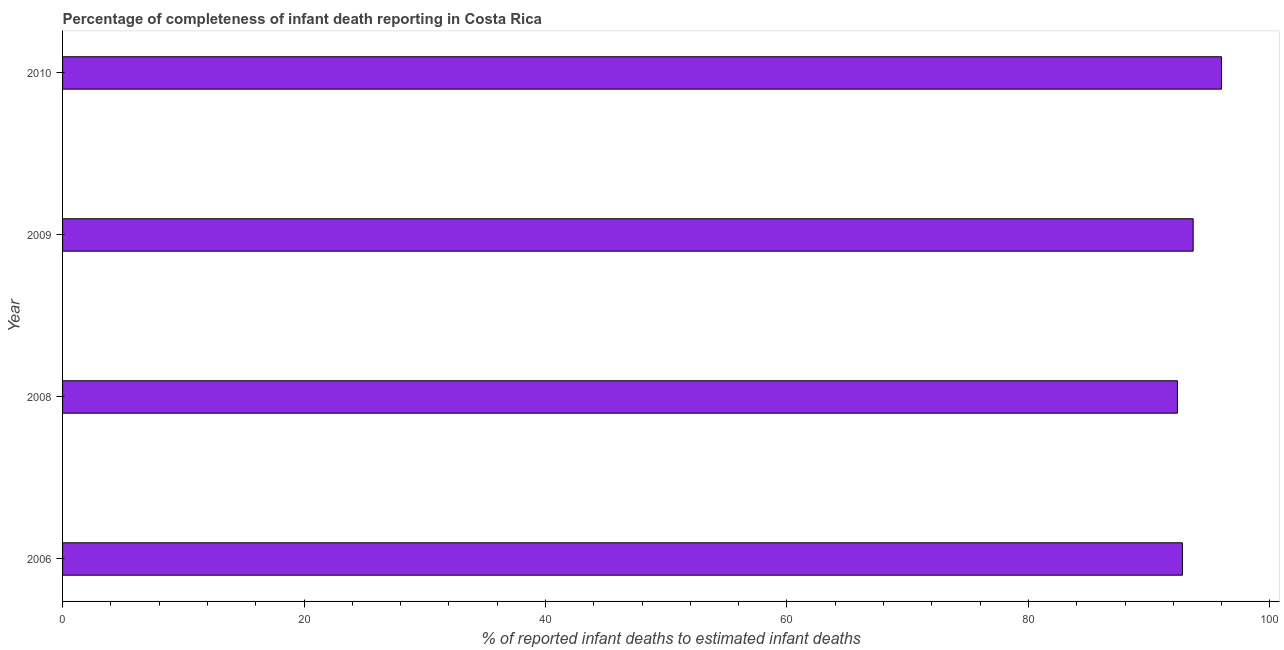What is the title of the graph?
Keep it short and to the point. Percentage of completeness of infant death reporting in Costa Rica. What is the label or title of the X-axis?
Provide a succinct answer. % of reported infant deaths to estimated infant deaths. What is the completeness of infant death reporting in 2009?
Give a very brief answer. 93.64. Across all years, what is the maximum completeness of infant death reporting?
Make the answer very short. 95.99. Across all years, what is the minimum completeness of infant death reporting?
Your response must be concise. 92.34. What is the sum of the completeness of infant death reporting?
Give a very brief answer. 374.73. What is the difference between the completeness of infant death reporting in 2008 and 2010?
Your answer should be compact. -3.65. What is the average completeness of infant death reporting per year?
Offer a terse response. 93.68. What is the median completeness of infant death reporting?
Provide a succinct answer. 93.2. In how many years, is the completeness of infant death reporting greater than 40 %?
Offer a very short reply. 4. What is the ratio of the completeness of infant death reporting in 2006 to that in 2009?
Ensure brevity in your answer.  0.99. Is the completeness of infant death reporting in 2006 less than that in 2008?
Your answer should be very brief. No. What is the difference between the highest and the second highest completeness of infant death reporting?
Make the answer very short. 2.35. What is the difference between the highest and the lowest completeness of infant death reporting?
Offer a terse response. 3.65. In how many years, is the completeness of infant death reporting greater than the average completeness of infant death reporting taken over all years?
Offer a terse response. 1. Are all the bars in the graph horizontal?
Provide a succinct answer. Yes. How many years are there in the graph?
Give a very brief answer. 4. Are the values on the major ticks of X-axis written in scientific E-notation?
Your response must be concise. No. What is the % of reported infant deaths to estimated infant deaths in 2006?
Your answer should be compact. 92.75. What is the % of reported infant deaths to estimated infant deaths of 2008?
Your answer should be very brief. 92.34. What is the % of reported infant deaths to estimated infant deaths of 2009?
Make the answer very short. 93.64. What is the % of reported infant deaths to estimated infant deaths in 2010?
Your response must be concise. 95.99. What is the difference between the % of reported infant deaths to estimated infant deaths in 2006 and 2008?
Keep it short and to the point. 0.41. What is the difference between the % of reported infant deaths to estimated infant deaths in 2006 and 2009?
Keep it short and to the point. -0.89. What is the difference between the % of reported infant deaths to estimated infant deaths in 2006 and 2010?
Keep it short and to the point. -3.24. What is the difference between the % of reported infant deaths to estimated infant deaths in 2008 and 2009?
Provide a succinct answer. -1.3. What is the difference between the % of reported infant deaths to estimated infant deaths in 2008 and 2010?
Offer a terse response. -3.65. What is the difference between the % of reported infant deaths to estimated infant deaths in 2009 and 2010?
Make the answer very short. -2.35. What is the ratio of the % of reported infant deaths to estimated infant deaths in 2006 to that in 2008?
Give a very brief answer. 1. What is the ratio of the % of reported infant deaths to estimated infant deaths in 2006 to that in 2009?
Offer a terse response. 0.99. What is the ratio of the % of reported infant deaths to estimated infant deaths in 2009 to that in 2010?
Your answer should be compact. 0.98. 